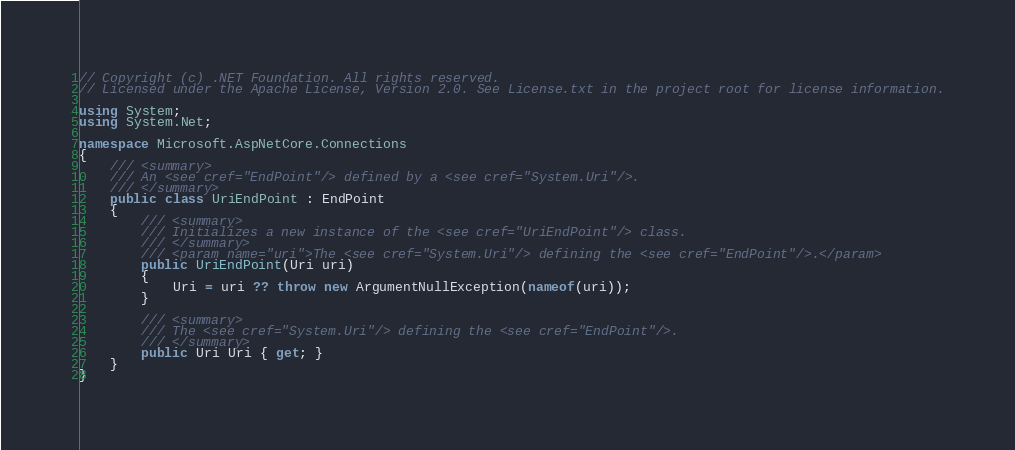Convert code to text. <code><loc_0><loc_0><loc_500><loc_500><_C#_>// Copyright (c) .NET Foundation. All rights reserved.
// Licensed under the Apache License, Version 2.0. See License.txt in the project root for license information.

using System;
using System.Net;

namespace Microsoft.AspNetCore.Connections
{
    /// <summary>
    /// An <see cref="EndPoint"/> defined by a <see cref="System.Uri"/>.
    /// </summary>
    public class UriEndPoint : EndPoint
    {
        /// <summary>
        /// Initializes a new instance of the <see cref="UriEndPoint"/> class.
        /// </summary>
        /// <param name="uri">The <see cref="System.Uri"/> defining the <see cref="EndPoint"/>.</param>
        public UriEndPoint(Uri uri)
        {
            Uri = uri ?? throw new ArgumentNullException(nameof(uri));
        }

        /// <summary>
        /// The <see cref="System.Uri"/> defining the <see cref="EndPoint"/>.
        /// </summary>
        public Uri Uri { get; }
    }
}
</code> 